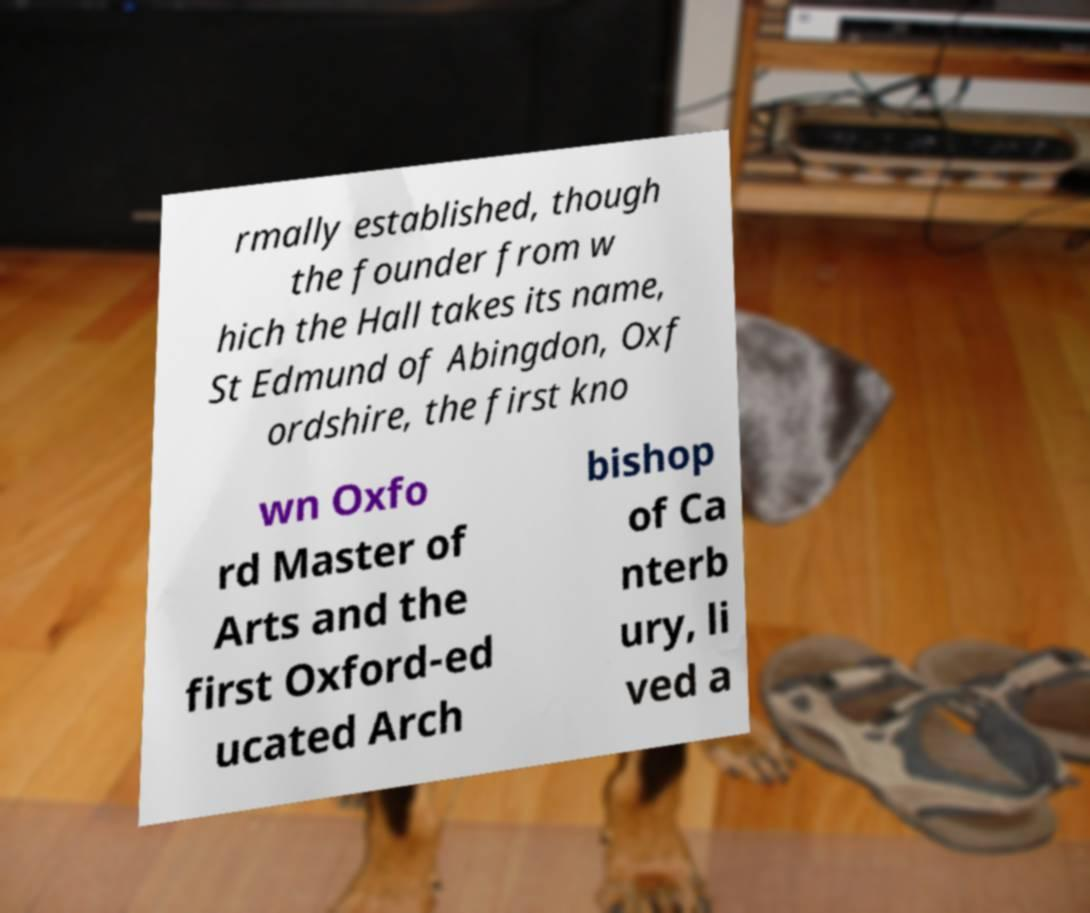I need the written content from this picture converted into text. Can you do that? rmally established, though the founder from w hich the Hall takes its name, St Edmund of Abingdon, Oxf ordshire, the first kno wn Oxfo rd Master of Arts and the first Oxford-ed ucated Arch bishop of Ca nterb ury, li ved a 